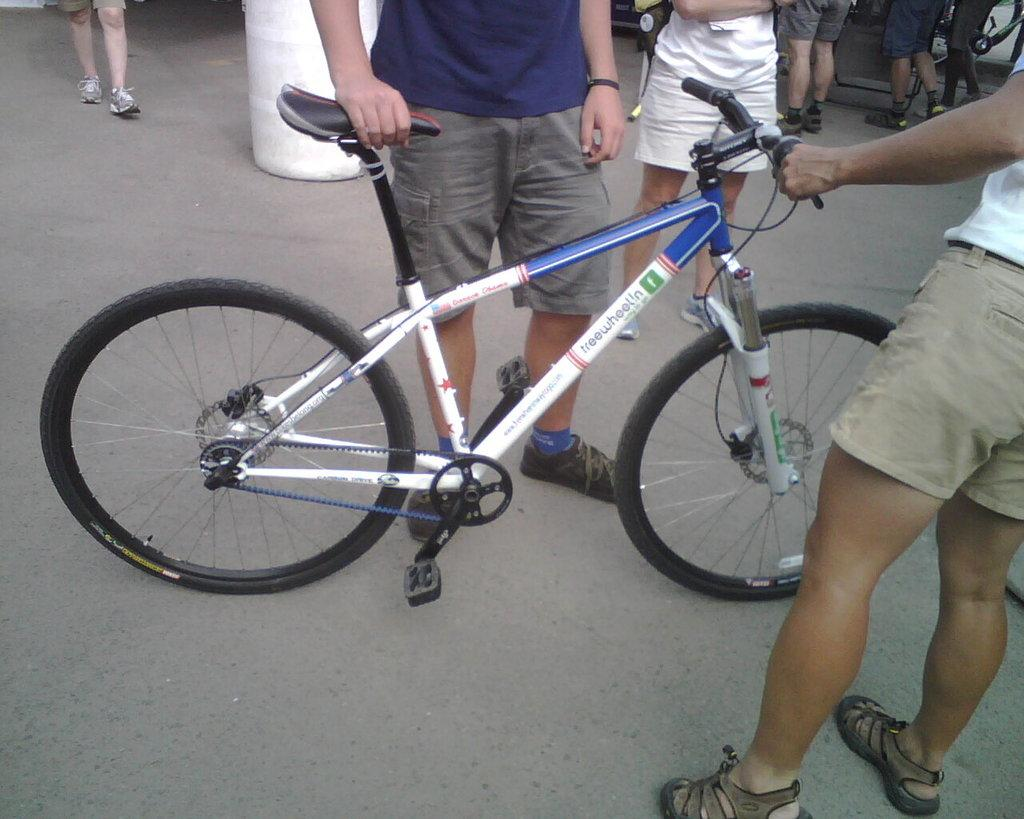How many people are present in the image? There are two people in the image. What are the two people doing in the image? The two people are holding bicycles. Can you describe the background of the image? There are people visible in the background of the image. What type of fire can be seen burning in the image? There is no fire present in the image. What is the common interest shared by the two people in the image? The provided facts do not mention any common interest between the two people. How many fingers can be seen on the hand of the person on the left side of the image? The provided facts do not mention any specific details about the hands or fingers of the two people. 